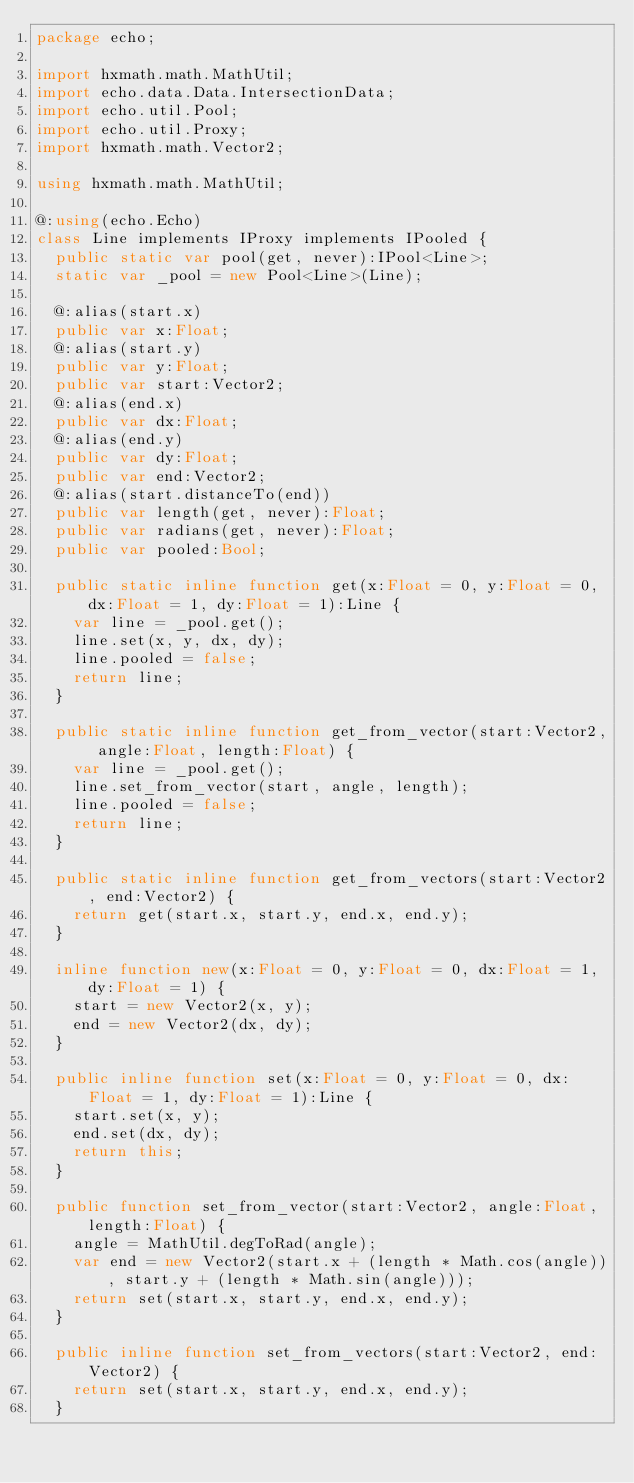<code> <loc_0><loc_0><loc_500><loc_500><_Haxe_>package echo;

import hxmath.math.MathUtil;
import echo.data.Data.IntersectionData;
import echo.util.Pool;
import echo.util.Proxy;
import hxmath.math.Vector2;

using hxmath.math.MathUtil;

@:using(echo.Echo)
class Line implements IProxy implements IPooled {
  public static var pool(get, never):IPool<Line>;
  static var _pool = new Pool<Line>(Line);

  @:alias(start.x)
  public var x:Float;
  @:alias(start.y)
  public var y:Float;
  public var start:Vector2;
  @:alias(end.x)
  public var dx:Float;
  @:alias(end.y)
  public var dy:Float;
  public var end:Vector2;
  @:alias(start.distanceTo(end))
  public var length(get, never):Float;
  public var radians(get, never):Float;
  public var pooled:Bool;

  public static inline function get(x:Float = 0, y:Float = 0, dx:Float = 1, dy:Float = 1):Line {
    var line = _pool.get();
    line.set(x, y, dx, dy);
    line.pooled = false;
    return line;
  }

  public static inline function get_from_vector(start:Vector2, angle:Float, length:Float) {
    var line = _pool.get();
    line.set_from_vector(start, angle, length);
    line.pooled = false;
    return line;
  }

  public static inline function get_from_vectors(start:Vector2, end:Vector2) {
    return get(start.x, start.y, end.x, end.y);
  }

  inline function new(x:Float = 0, y:Float = 0, dx:Float = 1, dy:Float = 1) {
    start = new Vector2(x, y);
    end = new Vector2(dx, dy);
  }

  public inline function set(x:Float = 0, y:Float = 0, dx:Float = 1, dy:Float = 1):Line {
    start.set(x, y);
    end.set(dx, dy);
    return this;
  }

  public function set_from_vector(start:Vector2, angle:Float, length:Float) {
    angle = MathUtil.degToRad(angle);
    var end = new Vector2(start.x + (length * Math.cos(angle)), start.y + (length * Math.sin(angle)));
    return set(start.x, start.y, end.x, end.y);
  }

  public inline function set_from_vectors(start:Vector2, end:Vector2) {
    return set(start.x, start.y, end.x, end.y);
  }
</code> 